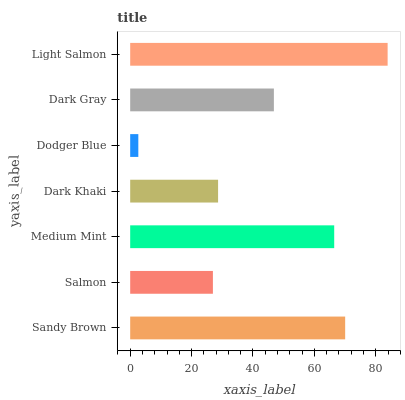Is Dodger Blue the minimum?
Answer yes or no. Yes. Is Light Salmon the maximum?
Answer yes or no. Yes. Is Salmon the minimum?
Answer yes or no. No. Is Salmon the maximum?
Answer yes or no. No. Is Sandy Brown greater than Salmon?
Answer yes or no. Yes. Is Salmon less than Sandy Brown?
Answer yes or no. Yes. Is Salmon greater than Sandy Brown?
Answer yes or no. No. Is Sandy Brown less than Salmon?
Answer yes or no. No. Is Dark Gray the high median?
Answer yes or no. Yes. Is Dark Gray the low median?
Answer yes or no. Yes. Is Dark Khaki the high median?
Answer yes or no. No. Is Light Salmon the low median?
Answer yes or no. No. 